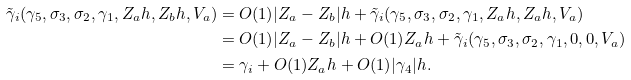<formula> <loc_0><loc_0><loc_500><loc_500>\tilde { \gamma } _ { i } ( \gamma _ { 5 } , \sigma _ { 3 } , \sigma _ { 2 } , \gamma _ { 1 } , Z _ { a } h , Z _ { b } h , V _ { a } ) & = O ( 1 ) | Z _ { a } - Z _ { b } | h + \tilde { \gamma } _ { i } ( \gamma _ { 5 } , \sigma _ { 3 } , \sigma _ { 2 } , \gamma _ { 1 } , Z _ { a } h , Z _ { a } h , V _ { a } ) \\ & = O ( 1 ) | Z _ { a } - Z _ { b } | h + O ( 1 ) Z _ { a } h + \tilde { \gamma } _ { i } ( \gamma _ { 5 } , \sigma _ { 3 } , \sigma _ { 2 } , \gamma _ { 1 } , 0 , 0 , V _ { a } ) \\ & = \gamma _ { i } + O ( 1 ) Z _ { a } h + O ( 1 ) | \gamma _ { 4 } | h .</formula> 